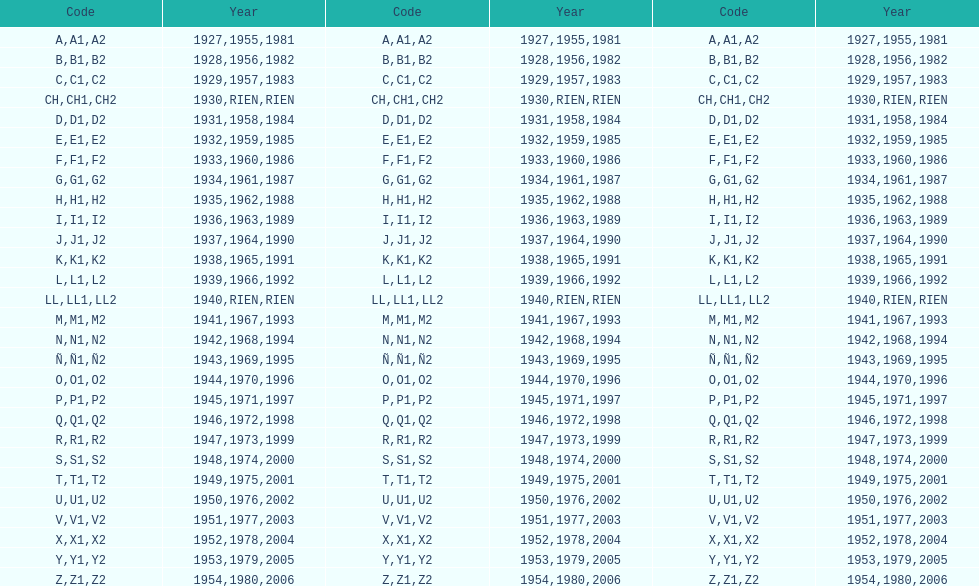What was the lowest year stamped? 1927. 